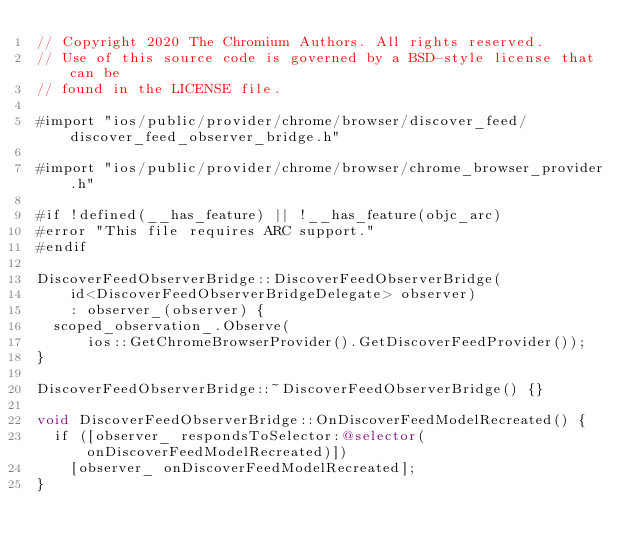<code> <loc_0><loc_0><loc_500><loc_500><_ObjectiveC_>// Copyright 2020 The Chromium Authors. All rights reserved.
// Use of this source code is governed by a BSD-style license that can be
// found in the LICENSE file.

#import "ios/public/provider/chrome/browser/discover_feed/discover_feed_observer_bridge.h"

#import "ios/public/provider/chrome/browser/chrome_browser_provider.h"

#if !defined(__has_feature) || !__has_feature(objc_arc)
#error "This file requires ARC support."
#endif

DiscoverFeedObserverBridge::DiscoverFeedObserverBridge(
    id<DiscoverFeedObserverBridgeDelegate> observer)
    : observer_(observer) {
  scoped_observation_.Observe(
      ios::GetChromeBrowserProvider().GetDiscoverFeedProvider());
}

DiscoverFeedObserverBridge::~DiscoverFeedObserverBridge() {}

void DiscoverFeedObserverBridge::OnDiscoverFeedModelRecreated() {
  if ([observer_ respondsToSelector:@selector(onDiscoverFeedModelRecreated)])
    [observer_ onDiscoverFeedModelRecreated];
}
</code> 